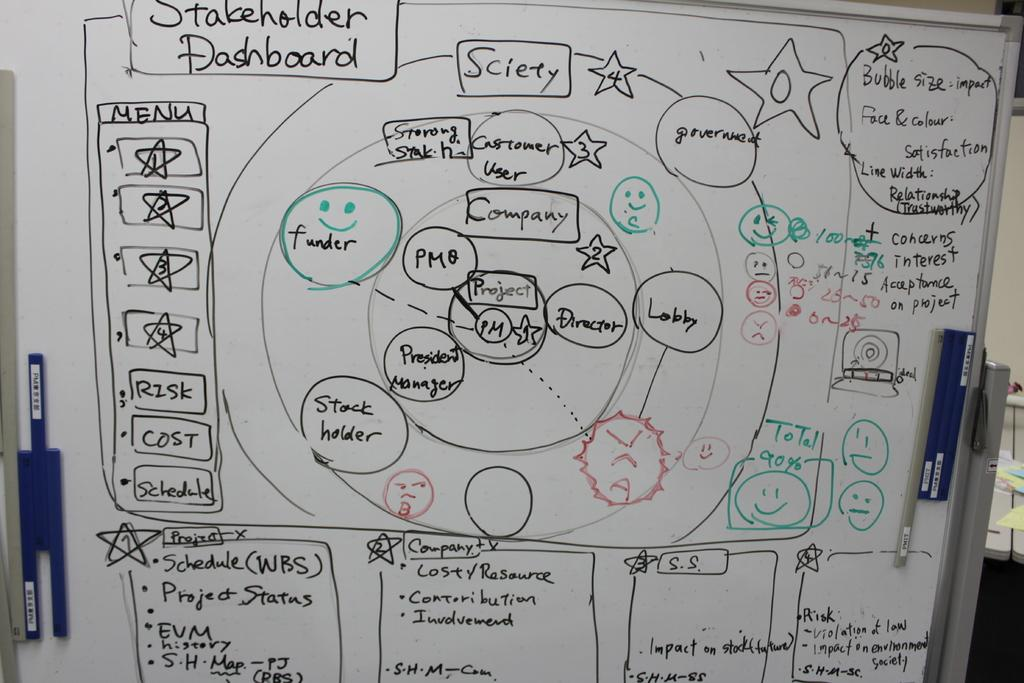What is the main object in the image? There is a whiteboard in the image. What is written on the whiteboard? There is handwritten text on the whiteboard. What type of stew is being prepared on the whiteboard? There is no stew or cooking activity depicted on the whiteboard; it only contains handwritten text. 